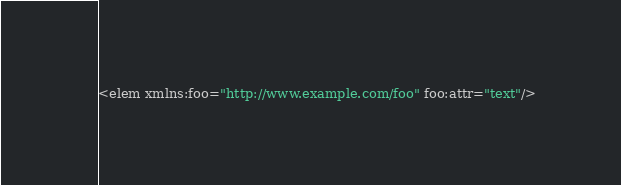<code> <loc_0><loc_0><loc_500><loc_500><_XML_><elem xmlns:foo="http://www.example.com/foo" foo:attr="text"/></code> 